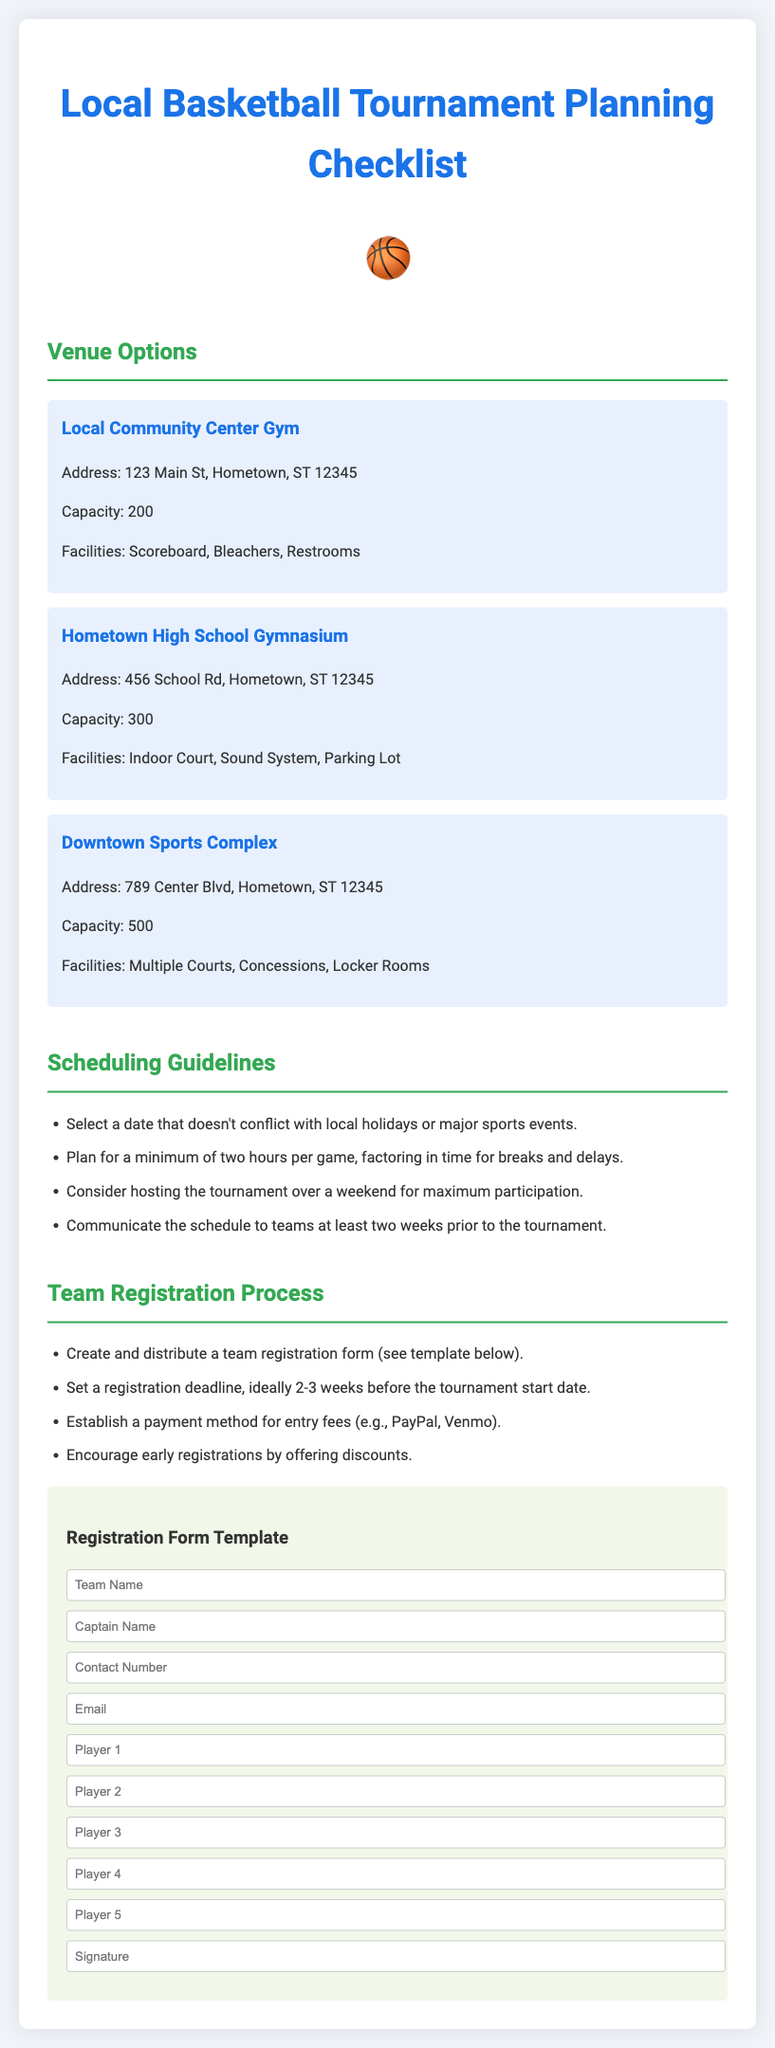What is the capacity of the Downtown Sports Complex? The capacity is listed under the venue options as the number of individuals the venue can accommodate, which is 500.
Answer: 500 What is the address of the Hometown High School Gymnasium? The address provides the location of the venue for reference within the document under venue options.
Answer: 456 School Rd, Hometown, ST 12345 How long should each game be planned for? The document specifies the time allocation for organizing the tournament in the scheduling guidelines section.
Answer: Minimum of two hours What deadline is recommended for team registration? The suggested deadline is stated explicitly in the team registration process section, encouraging good planning practices.
Answer: 2-3 weeks before Which payment methods are suggested for entry fees? This method is mentioned in the team registration process as acceptable ways to collect fees.
Answer: PayPal, Venmo What should be communicated to teams at least two weeks prior? This information pertains to scheduling within the tournament planning, emphasizing communication to ensure participation.
Answer: The schedule What facilities are available at the Local Community Center Gym? Facilities are listed to describe the amenities at the venue options, demonstrating what teams can expect.
Answer: Scoreboard, Bleachers, Restrooms What is the main theme icon representing basketball in the document? The document features this emoji to visually enhance the topic of basketball tournaments.
Answer: 🏀 What should be included in the Registration Form Template? This refers to the fields that need to be filled out by teams as specified in the registration process.
Answer: Team Name, Captain Name, Contact Number, Email, Player 1, Player 2, Player 3, Player 4, Player 5, Signature 